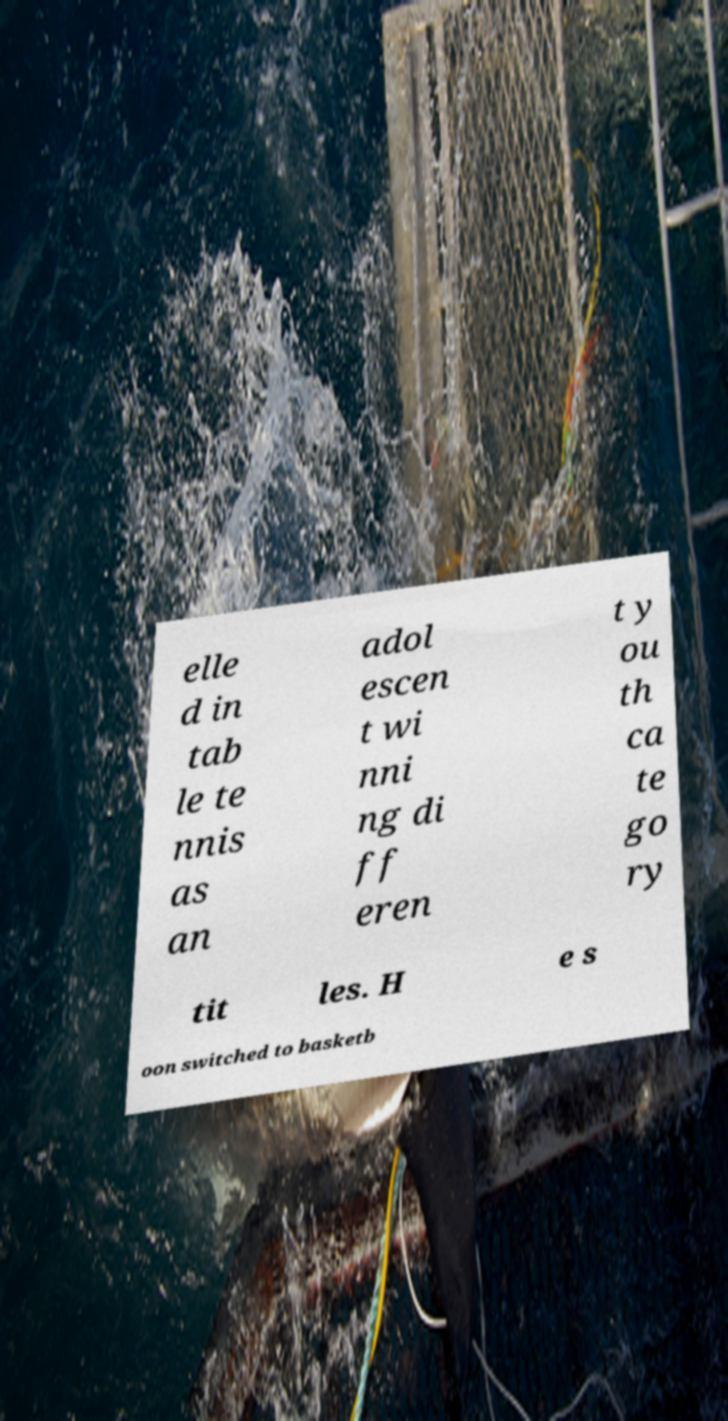Can you accurately transcribe the text from the provided image for me? elle d in tab le te nnis as an adol escen t wi nni ng di ff eren t y ou th ca te go ry tit les. H e s oon switched to basketb 